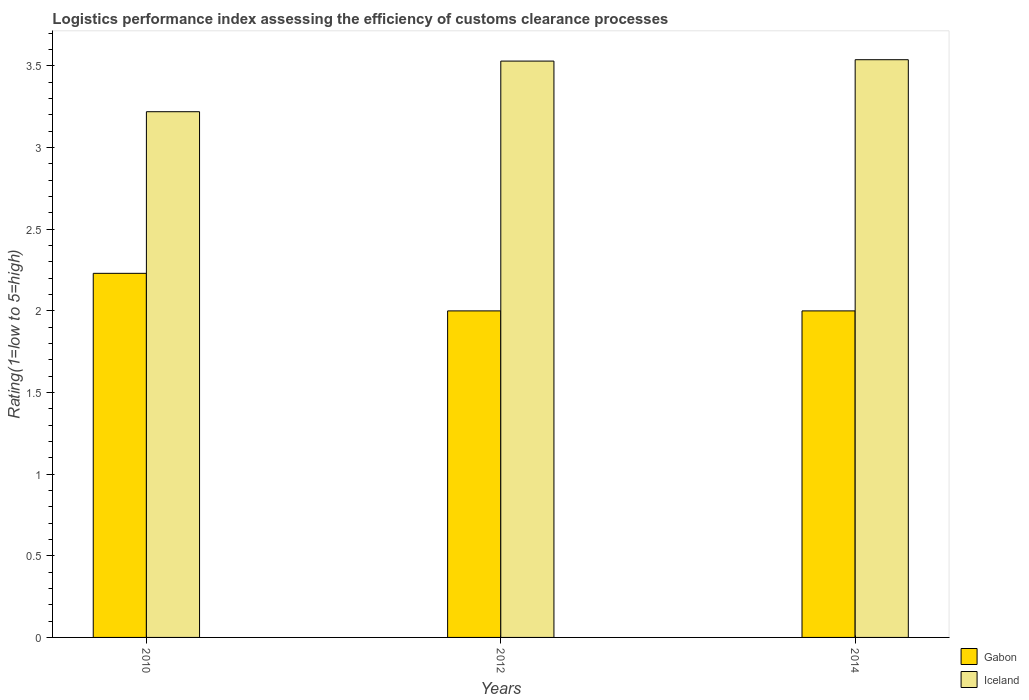How many different coloured bars are there?
Offer a terse response. 2. How many groups of bars are there?
Ensure brevity in your answer.  3. Are the number of bars per tick equal to the number of legend labels?
Your response must be concise. Yes. Are the number of bars on each tick of the X-axis equal?
Offer a very short reply. Yes. How many bars are there on the 1st tick from the left?
Provide a succinct answer. 2. How many bars are there on the 1st tick from the right?
Your answer should be compact. 2. What is the label of the 3rd group of bars from the left?
Keep it short and to the point. 2014. In how many cases, is the number of bars for a given year not equal to the number of legend labels?
Provide a succinct answer. 0. Across all years, what is the maximum Logistic performance index in Gabon?
Your answer should be very brief. 2.23. Across all years, what is the minimum Logistic performance index in Iceland?
Your answer should be very brief. 3.22. In which year was the Logistic performance index in Iceland maximum?
Ensure brevity in your answer.  2014. What is the total Logistic performance index in Iceland in the graph?
Give a very brief answer. 10.29. What is the difference between the Logistic performance index in Gabon in 2010 and that in 2014?
Provide a short and direct response. 0.23. What is the difference between the Logistic performance index in Iceland in 2010 and the Logistic performance index in Gabon in 2012?
Make the answer very short. 1.22. What is the average Logistic performance index in Gabon per year?
Give a very brief answer. 2.08. In the year 2012, what is the difference between the Logistic performance index in Iceland and Logistic performance index in Gabon?
Provide a succinct answer. 1.53. What is the ratio of the Logistic performance index in Gabon in 2012 to that in 2014?
Your response must be concise. 1. What is the difference between the highest and the second highest Logistic performance index in Gabon?
Your answer should be compact. 0.23. What is the difference between the highest and the lowest Logistic performance index in Iceland?
Make the answer very short. 0.32. In how many years, is the Logistic performance index in Iceland greater than the average Logistic performance index in Iceland taken over all years?
Make the answer very short. 2. Is the sum of the Logistic performance index in Iceland in 2012 and 2014 greater than the maximum Logistic performance index in Gabon across all years?
Your answer should be compact. Yes. What does the 2nd bar from the left in 2012 represents?
Make the answer very short. Iceland. What does the 2nd bar from the right in 2012 represents?
Your response must be concise. Gabon. Are all the bars in the graph horizontal?
Your answer should be compact. No. How many years are there in the graph?
Make the answer very short. 3. Are the values on the major ticks of Y-axis written in scientific E-notation?
Offer a very short reply. No. Does the graph contain any zero values?
Offer a terse response. No. Does the graph contain grids?
Make the answer very short. No. Where does the legend appear in the graph?
Your answer should be compact. Bottom right. How many legend labels are there?
Keep it short and to the point. 2. What is the title of the graph?
Your answer should be very brief. Logistics performance index assessing the efficiency of customs clearance processes. Does "St. Martin (French part)" appear as one of the legend labels in the graph?
Provide a succinct answer. No. What is the label or title of the Y-axis?
Ensure brevity in your answer.  Rating(1=low to 5=high). What is the Rating(1=low to 5=high) of Gabon in 2010?
Provide a succinct answer. 2.23. What is the Rating(1=low to 5=high) in Iceland in 2010?
Your answer should be compact. 3.22. What is the Rating(1=low to 5=high) in Iceland in 2012?
Your answer should be compact. 3.53. What is the Rating(1=low to 5=high) of Iceland in 2014?
Your answer should be very brief. 3.54. Across all years, what is the maximum Rating(1=low to 5=high) in Gabon?
Your response must be concise. 2.23. Across all years, what is the maximum Rating(1=low to 5=high) of Iceland?
Make the answer very short. 3.54. Across all years, what is the minimum Rating(1=low to 5=high) of Gabon?
Give a very brief answer. 2. Across all years, what is the minimum Rating(1=low to 5=high) of Iceland?
Your answer should be very brief. 3.22. What is the total Rating(1=low to 5=high) of Gabon in the graph?
Make the answer very short. 6.23. What is the total Rating(1=low to 5=high) in Iceland in the graph?
Your answer should be compact. 10.29. What is the difference between the Rating(1=low to 5=high) in Gabon in 2010 and that in 2012?
Your answer should be compact. 0.23. What is the difference between the Rating(1=low to 5=high) of Iceland in 2010 and that in 2012?
Offer a terse response. -0.31. What is the difference between the Rating(1=low to 5=high) of Gabon in 2010 and that in 2014?
Offer a terse response. 0.23. What is the difference between the Rating(1=low to 5=high) in Iceland in 2010 and that in 2014?
Give a very brief answer. -0.32. What is the difference between the Rating(1=low to 5=high) in Iceland in 2012 and that in 2014?
Make the answer very short. -0.01. What is the difference between the Rating(1=low to 5=high) in Gabon in 2010 and the Rating(1=low to 5=high) in Iceland in 2012?
Keep it short and to the point. -1.3. What is the difference between the Rating(1=low to 5=high) of Gabon in 2010 and the Rating(1=low to 5=high) of Iceland in 2014?
Give a very brief answer. -1.31. What is the difference between the Rating(1=low to 5=high) in Gabon in 2012 and the Rating(1=low to 5=high) in Iceland in 2014?
Provide a succinct answer. -1.54. What is the average Rating(1=low to 5=high) of Gabon per year?
Offer a terse response. 2.08. What is the average Rating(1=low to 5=high) in Iceland per year?
Give a very brief answer. 3.43. In the year 2010, what is the difference between the Rating(1=low to 5=high) of Gabon and Rating(1=low to 5=high) of Iceland?
Provide a short and direct response. -0.99. In the year 2012, what is the difference between the Rating(1=low to 5=high) in Gabon and Rating(1=low to 5=high) in Iceland?
Provide a succinct answer. -1.53. In the year 2014, what is the difference between the Rating(1=low to 5=high) of Gabon and Rating(1=low to 5=high) of Iceland?
Provide a succinct answer. -1.54. What is the ratio of the Rating(1=low to 5=high) in Gabon in 2010 to that in 2012?
Your response must be concise. 1.11. What is the ratio of the Rating(1=low to 5=high) in Iceland in 2010 to that in 2012?
Your response must be concise. 0.91. What is the ratio of the Rating(1=low to 5=high) of Gabon in 2010 to that in 2014?
Your answer should be compact. 1.11. What is the ratio of the Rating(1=low to 5=high) of Iceland in 2010 to that in 2014?
Make the answer very short. 0.91. What is the difference between the highest and the second highest Rating(1=low to 5=high) in Gabon?
Your answer should be compact. 0.23. What is the difference between the highest and the second highest Rating(1=low to 5=high) of Iceland?
Give a very brief answer. 0.01. What is the difference between the highest and the lowest Rating(1=low to 5=high) of Gabon?
Your response must be concise. 0.23. What is the difference between the highest and the lowest Rating(1=low to 5=high) in Iceland?
Give a very brief answer. 0.32. 